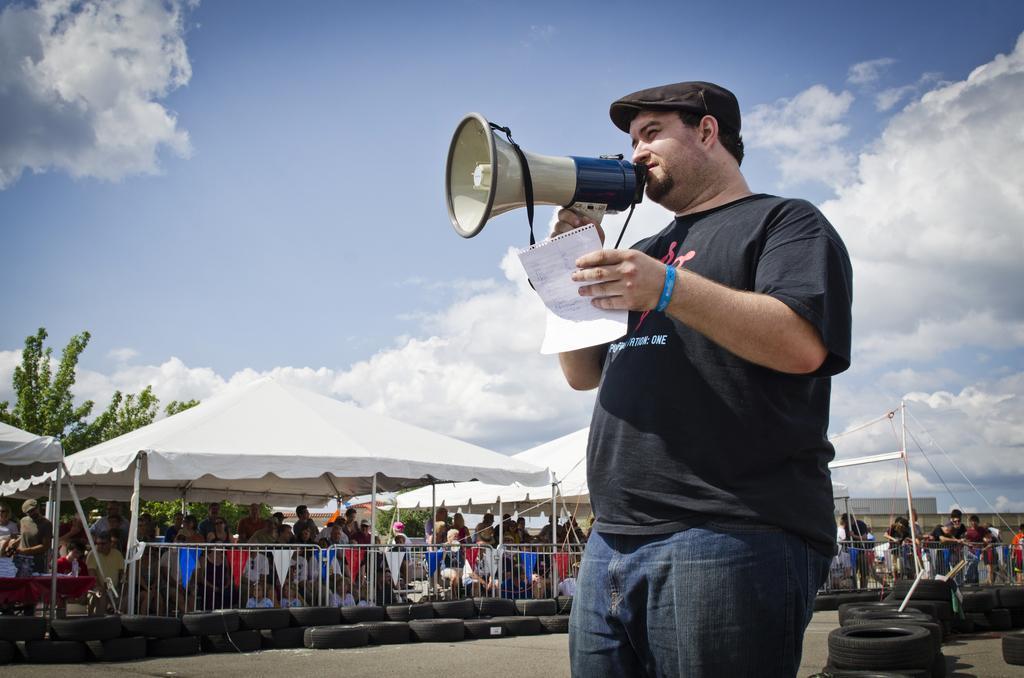Please provide a concise description of this image. In the image there is a man announcing something through a speaker and behind the man there are many wheels and there is a fencing around that area and behind the fencing there is a huge crowd. 